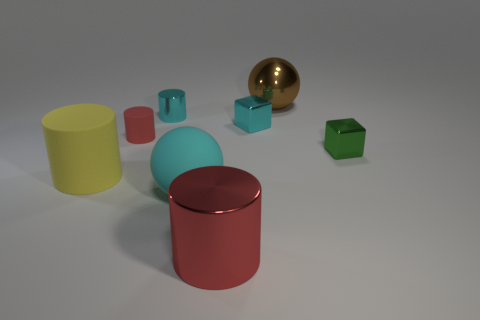Subtract all yellow spheres. How many red cylinders are left? 2 Subtract all tiny matte cylinders. How many cylinders are left? 3 Subtract all cyan cylinders. How many cylinders are left? 3 Add 1 cyan blocks. How many objects exist? 9 Subtract all balls. How many objects are left? 6 Subtract all brown cylinders. Subtract all green spheres. How many cylinders are left? 4 Add 2 big green cubes. How many big green cubes exist? 2 Subtract 0 blue spheres. How many objects are left? 8 Subtract all big cyan rubber objects. Subtract all big brown balls. How many objects are left? 6 Add 1 large yellow rubber cylinders. How many large yellow rubber cylinders are left? 2 